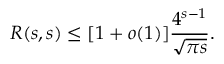<formula> <loc_0><loc_0><loc_500><loc_500>R ( s , s ) \leq [ 1 + o ( 1 ) ] { \frac { 4 ^ { s - 1 } } { \sqrt { \pi s } } } .</formula> 